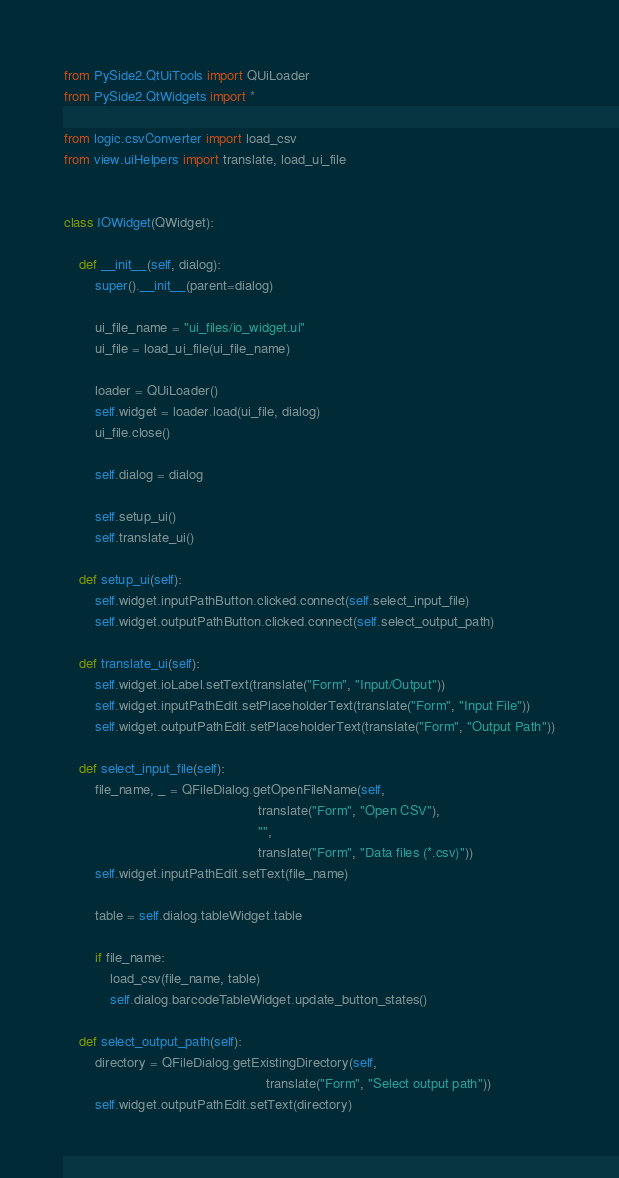Convert code to text. <code><loc_0><loc_0><loc_500><loc_500><_Python_>from PySide2.QtUiTools import QUiLoader
from PySide2.QtWidgets import *

from logic.csvConverter import load_csv
from view.uiHelpers import translate, load_ui_file


class IOWidget(QWidget):

    def __init__(self, dialog):
        super().__init__(parent=dialog)

        ui_file_name = "ui_files/io_widget.ui"
        ui_file = load_ui_file(ui_file_name)

        loader = QUiLoader()
        self.widget = loader.load(ui_file, dialog)
        ui_file.close()

        self.dialog = dialog

        self.setup_ui()
        self.translate_ui()

    def setup_ui(self):
        self.widget.inputPathButton.clicked.connect(self.select_input_file)
        self.widget.outputPathButton.clicked.connect(self.select_output_path)

    def translate_ui(self):
        self.widget.ioLabel.setText(translate("Form", "Input/Output"))
        self.widget.inputPathEdit.setPlaceholderText(translate("Form", "Input File"))
        self.widget.outputPathEdit.setPlaceholderText(translate("Form", "Output Path"))

    def select_input_file(self):
        file_name, _ = QFileDialog.getOpenFileName(self,
                                                   translate("Form", "Open CSV"),
                                                   "",
                                                   translate("Form", "Data files (*.csv)"))
        self.widget.inputPathEdit.setText(file_name)

        table = self.dialog.tableWidget.table

        if file_name:
            load_csv(file_name, table)
            self.dialog.barcodeTableWidget.update_button_states()

    def select_output_path(self):
        directory = QFileDialog.getExistingDirectory(self,
                                                     translate("Form", "Select output path"))
        self.widget.outputPathEdit.setText(directory)
</code> 